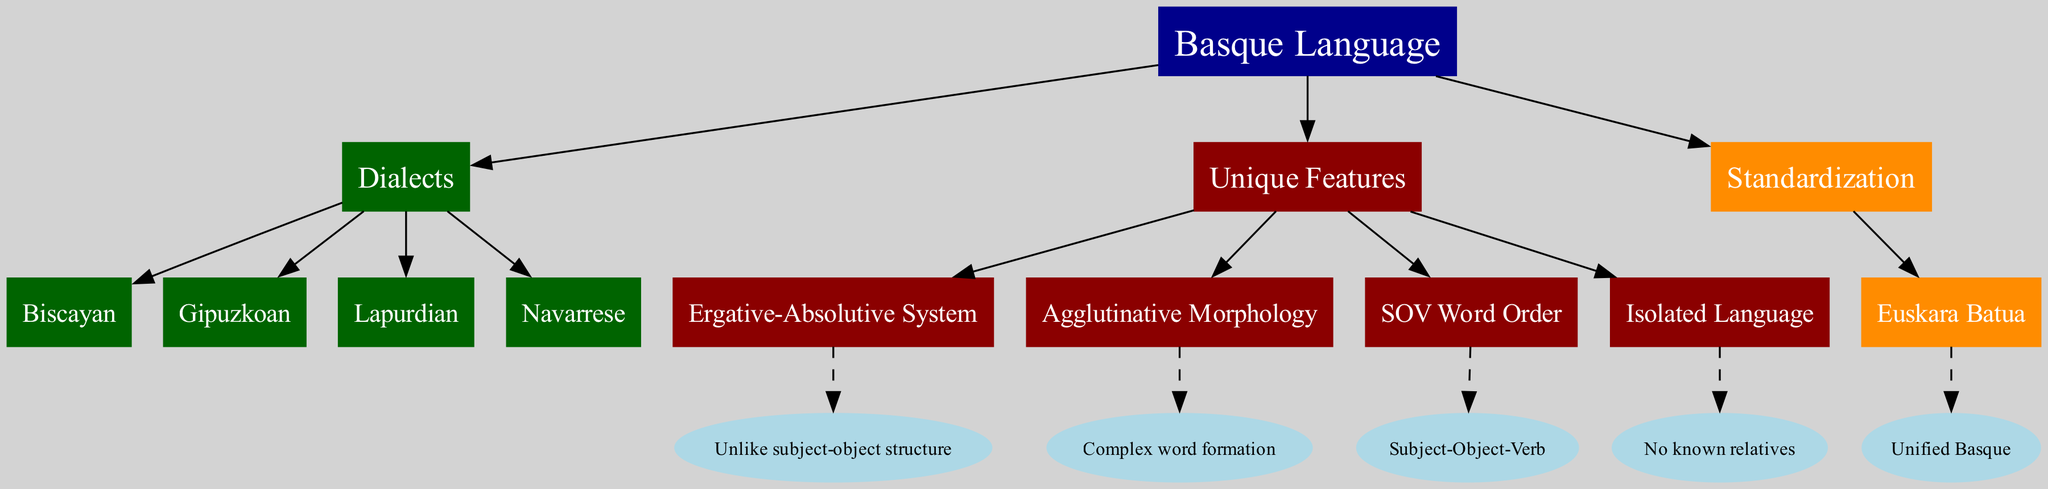What's the root node of the diagram? The root node is labeled "Basque Language," which is the starting point of the family tree representing the Basque language and its features.
Answer: Basque Language How many dialects are represented in the diagram? The diagram includes four dialects listed under the "Dialects" branch: Biscayan, Gipuzkoan, Lapurdian, and Navarrese. Therefore, counting them gives a total of four.
Answer: 4 What is the unique feature described by "Isolated Language"? The "Isolated Language" feature indicates that the Basque language has no known relatives, making it unique in its classification.
Answer: No known relatives What color represents the "Unique Features" branch? The "Unique Features" branch is colored dark red, distinguishing it visually from other branches in the diagram.
Answer: Dark red Which dialect is listed first in the diagram? The first dialect listed under the "Dialects" branch is Biscayan, making it prominent in the diagram's layout.
Answer: Biscayan Which unique feature refers to the structure of sentences in the Basque language? The "SOV Word Order" feature refers to the structure of sentences, indicating that the typical order is Subject-Object-Verb.
Answer: SOV Word Order How many unique features are mentioned in the diagram? The diagram lists four unique features of the Basque language, which are Ergative-Absolutive System, Agglutinative Morphology, SOV Word Order, and Isolated Language.
Answer: 4 What does "Euskara Batua" represent? "Euskara Batua" is labeled under the "Standardization" branch, and it represents the concept of Unified Basque, which is a standardized form of the language.
Answer: Unified Basque What unique feature involves word formation complexity? The unique feature "Agglutinative Morphology" describes the complexity of word formation in the Basque language, highlighting its linguistic characteristics.
Answer: Agglutinative Morphology 